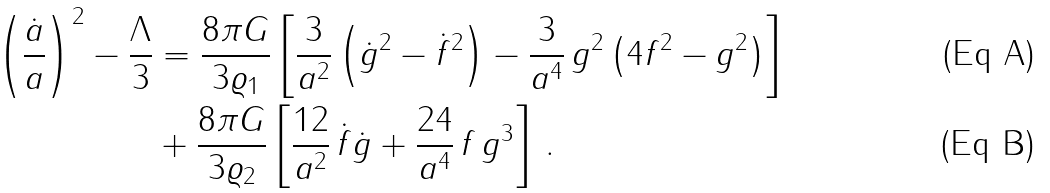Convert formula to latex. <formula><loc_0><loc_0><loc_500><loc_500>\left ( \frac { \dot { a } } { a } \right ) ^ { 2 } - \frac { \Lambda } { 3 } & = \frac { 8 \pi G } { 3 \varrho _ { 1 } } \left [ \frac { 3 } { a ^ { 2 } } \left ( \dot { g } ^ { 2 } - \dot { f } ^ { 2 } \right ) - \frac { 3 } { a ^ { 4 } } \, g ^ { 2 } \left ( 4 f ^ { 2 } - g ^ { 2 } \right ) \right ] \\ & + \frac { 8 \pi G } { 3 \varrho _ { 2 } } \left [ \frac { 1 2 } { a ^ { 2 } } \, \dot { f } \dot { g } + \frac { 2 4 } { a ^ { 4 } } \, f \, g ^ { 3 } \right ] \, .</formula> 